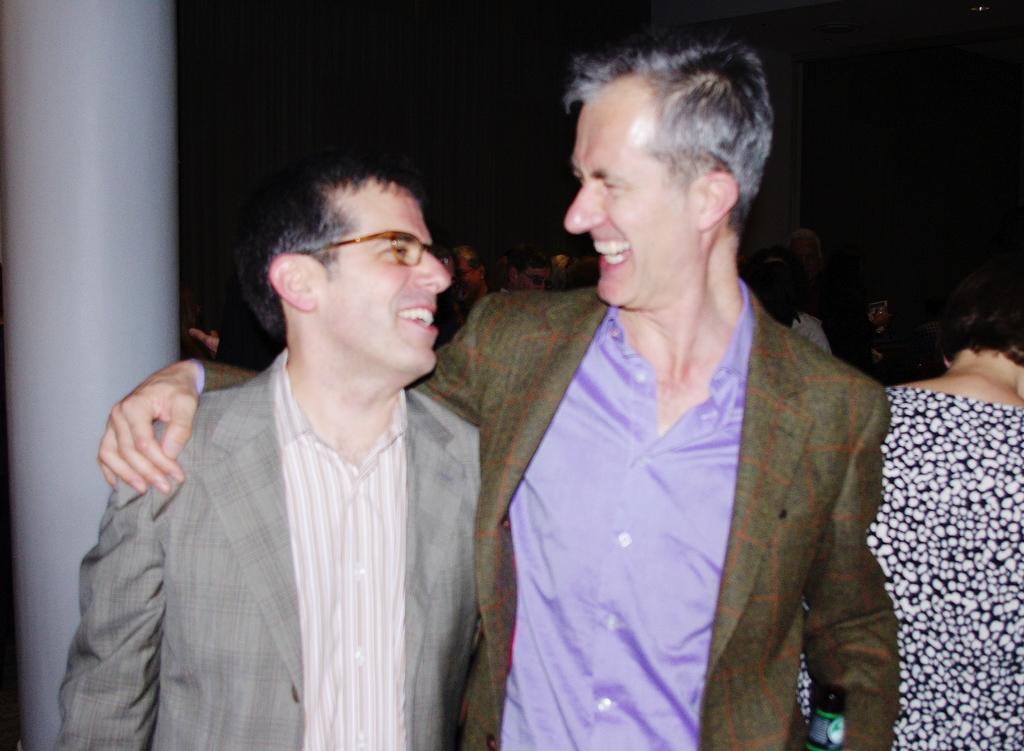Could you give a brief overview of what you see in this image? In this there is a person wearing a blazer. Beside him there is a person wearing spectacles and a blazer. Behind them there are people. Left side there is a pillar. 